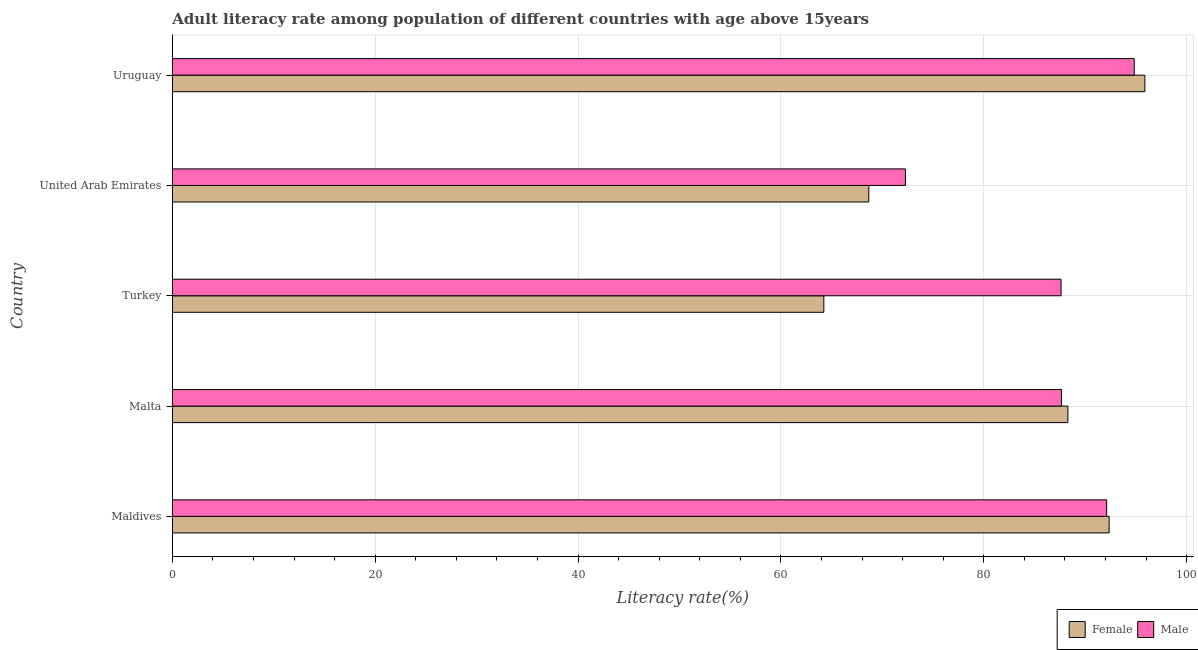How many groups of bars are there?
Your response must be concise. 5. Are the number of bars per tick equal to the number of legend labels?
Ensure brevity in your answer.  Yes. How many bars are there on the 2nd tick from the top?
Provide a succinct answer. 2. What is the label of the 2nd group of bars from the top?
Offer a terse response. United Arab Emirates. What is the male adult literacy rate in Maldives?
Ensure brevity in your answer.  92.11. Across all countries, what is the maximum male adult literacy rate?
Provide a succinct answer. 94.83. Across all countries, what is the minimum male adult literacy rate?
Your response must be concise. 72.27. In which country was the male adult literacy rate maximum?
Keep it short and to the point. Uruguay. In which country was the male adult literacy rate minimum?
Provide a succinct answer. United Arab Emirates. What is the total male adult literacy rate in the graph?
Your response must be concise. 434.5. What is the difference between the male adult literacy rate in Turkey and that in United Arab Emirates?
Give a very brief answer. 15.35. What is the difference between the male adult literacy rate in Malta and the female adult literacy rate in Maldives?
Make the answer very short. -4.7. What is the average male adult literacy rate per country?
Provide a short and direct response. 86.9. What is the difference between the male adult literacy rate and female adult literacy rate in United Arab Emirates?
Provide a short and direct response. 3.61. In how many countries, is the female adult literacy rate greater than 88 %?
Your response must be concise. 3. What is the ratio of the female adult literacy rate in Maldives to that in Turkey?
Your answer should be compact. 1.44. Is the difference between the male adult literacy rate in United Arab Emirates and Uruguay greater than the difference between the female adult literacy rate in United Arab Emirates and Uruguay?
Give a very brief answer. Yes. What is the difference between the highest and the second highest female adult literacy rate?
Give a very brief answer. 3.52. What is the difference between the highest and the lowest male adult literacy rate?
Your answer should be compact. 22.56. What does the 2nd bar from the top in Maldives represents?
Your answer should be compact. Female. What does the 1st bar from the bottom in Turkey represents?
Your answer should be compact. Female. Are all the bars in the graph horizontal?
Your answer should be very brief. Yes. How many countries are there in the graph?
Provide a short and direct response. 5. Are the values on the major ticks of X-axis written in scientific E-notation?
Keep it short and to the point. No. Does the graph contain any zero values?
Offer a terse response. No. Does the graph contain grids?
Keep it short and to the point. Yes. How many legend labels are there?
Offer a terse response. 2. How are the legend labels stacked?
Make the answer very short. Horizontal. What is the title of the graph?
Give a very brief answer. Adult literacy rate among population of different countries with age above 15years. Does "National Visitors" appear as one of the legend labels in the graph?
Offer a very short reply. No. What is the label or title of the X-axis?
Make the answer very short. Literacy rate(%). What is the label or title of the Y-axis?
Your response must be concise. Country. What is the Literacy rate(%) in Female in Maldives?
Your answer should be very brief. 92.36. What is the Literacy rate(%) of Male in Maldives?
Your response must be concise. 92.11. What is the Literacy rate(%) of Female in Malta?
Your answer should be very brief. 88.29. What is the Literacy rate(%) in Male in Malta?
Ensure brevity in your answer.  87.66. What is the Literacy rate(%) of Female in Turkey?
Your answer should be very brief. 64.23. What is the Literacy rate(%) of Male in Turkey?
Your answer should be very brief. 87.62. What is the Literacy rate(%) in Female in United Arab Emirates?
Keep it short and to the point. 68.66. What is the Literacy rate(%) of Male in United Arab Emirates?
Your response must be concise. 72.27. What is the Literacy rate(%) of Female in Uruguay?
Offer a terse response. 95.88. What is the Literacy rate(%) in Male in Uruguay?
Ensure brevity in your answer.  94.83. Across all countries, what is the maximum Literacy rate(%) of Female?
Keep it short and to the point. 95.88. Across all countries, what is the maximum Literacy rate(%) in Male?
Provide a succinct answer. 94.83. Across all countries, what is the minimum Literacy rate(%) in Female?
Provide a short and direct response. 64.23. Across all countries, what is the minimum Literacy rate(%) in Male?
Your response must be concise. 72.27. What is the total Literacy rate(%) in Female in the graph?
Provide a succinct answer. 409.43. What is the total Literacy rate(%) in Male in the graph?
Provide a short and direct response. 434.5. What is the difference between the Literacy rate(%) in Female in Maldives and that in Malta?
Give a very brief answer. 4.07. What is the difference between the Literacy rate(%) of Male in Maldives and that in Malta?
Offer a terse response. 4.46. What is the difference between the Literacy rate(%) in Female in Maldives and that in Turkey?
Provide a succinct answer. 28.13. What is the difference between the Literacy rate(%) of Male in Maldives and that in Turkey?
Your answer should be compact. 4.49. What is the difference between the Literacy rate(%) in Female in Maldives and that in United Arab Emirates?
Ensure brevity in your answer.  23.7. What is the difference between the Literacy rate(%) in Male in Maldives and that in United Arab Emirates?
Make the answer very short. 19.84. What is the difference between the Literacy rate(%) of Female in Maldives and that in Uruguay?
Your response must be concise. -3.52. What is the difference between the Literacy rate(%) of Male in Maldives and that in Uruguay?
Give a very brief answer. -2.72. What is the difference between the Literacy rate(%) of Female in Malta and that in Turkey?
Provide a short and direct response. 24.06. What is the difference between the Literacy rate(%) in Male in Malta and that in Turkey?
Offer a very short reply. 0.04. What is the difference between the Literacy rate(%) of Female in Malta and that in United Arab Emirates?
Make the answer very short. 19.63. What is the difference between the Literacy rate(%) of Male in Malta and that in United Arab Emirates?
Ensure brevity in your answer.  15.38. What is the difference between the Literacy rate(%) of Female in Malta and that in Uruguay?
Provide a succinct answer. -7.59. What is the difference between the Literacy rate(%) of Male in Malta and that in Uruguay?
Provide a succinct answer. -7.18. What is the difference between the Literacy rate(%) in Female in Turkey and that in United Arab Emirates?
Ensure brevity in your answer.  -4.43. What is the difference between the Literacy rate(%) of Male in Turkey and that in United Arab Emirates?
Your answer should be very brief. 15.35. What is the difference between the Literacy rate(%) of Female in Turkey and that in Uruguay?
Keep it short and to the point. -31.65. What is the difference between the Literacy rate(%) of Male in Turkey and that in Uruguay?
Ensure brevity in your answer.  -7.21. What is the difference between the Literacy rate(%) in Female in United Arab Emirates and that in Uruguay?
Offer a terse response. -27.22. What is the difference between the Literacy rate(%) of Male in United Arab Emirates and that in Uruguay?
Keep it short and to the point. -22.56. What is the difference between the Literacy rate(%) of Female in Maldives and the Literacy rate(%) of Male in Malta?
Provide a succinct answer. 4.7. What is the difference between the Literacy rate(%) of Female in Maldives and the Literacy rate(%) of Male in Turkey?
Your answer should be very brief. 4.74. What is the difference between the Literacy rate(%) of Female in Maldives and the Literacy rate(%) of Male in United Arab Emirates?
Your answer should be compact. 20.08. What is the difference between the Literacy rate(%) of Female in Maldives and the Literacy rate(%) of Male in Uruguay?
Your response must be concise. -2.47. What is the difference between the Literacy rate(%) in Female in Malta and the Literacy rate(%) in Male in Turkey?
Make the answer very short. 0.67. What is the difference between the Literacy rate(%) of Female in Malta and the Literacy rate(%) of Male in United Arab Emirates?
Offer a very short reply. 16.02. What is the difference between the Literacy rate(%) of Female in Malta and the Literacy rate(%) of Male in Uruguay?
Offer a terse response. -6.54. What is the difference between the Literacy rate(%) in Female in Turkey and the Literacy rate(%) in Male in United Arab Emirates?
Make the answer very short. -8.04. What is the difference between the Literacy rate(%) of Female in Turkey and the Literacy rate(%) of Male in Uruguay?
Your response must be concise. -30.6. What is the difference between the Literacy rate(%) in Female in United Arab Emirates and the Literacy rate(%) in Male in Uruguay?
Provide a succinct answer. -26.17. What is the average Literacy rate(%) of Female per country?
Keep it short and to the point. 81.89. What is the average Literacy rate(%) of Male per country?
Offer a very short reply. 86.9. What is the difference between the Literacy rate(%) in Female and Literacy rate(%) in Male in Maldives?
Your answer should be compact. 0.24. What is the difference between the Literacy rate(%) in Female and Literacy rate(%) in Male in Malta?
Your answer should be very brief. 0.64. What is the difference between the Literacy rate(%) in Female and Literacy rate(%) in Male in Turkey?
Give a very brief answer. -23.39. What is the difference between the Literacy rate(%) in Female and Literacy rate(%) in Male in United Arab Emirates?
Provide a succinct answer. -3.61. What is the difference between the Literacy rate(%) in Female and Literacy rate(%) in Male in Uruguay?
Provide a succinct answer. 1.05. What is the ratio of the Literacy rate(%) in Female in Maldives to that in Malta?
Your response must be concise. 1.05. What is the ratio of the Literacy rate(%) of Male in Maldives to that in Malta?
Keep it short and to the point. 1.05. What is the ratio of the Literacy rate(%) in Female in Maldives to that in Turkey?
Provide a succinct answer. 1.44. What is the ratio of the Literacy rate(%) in Male in Maldives to that in Turkey?
Offer a terse response. 1.05. What is the ratio of the Literacy rate(%) in Female in Maldives to that in United Arab Emirates?
Your response must be concise. 1.35. What is the ratio of the Literacy rate(%) in Male in Maldives to that in United Arab Emirates?
Provide a succinct answer. 1.27. What is the ratio of the Literacy rate(%) in Female in Maldives to that in Uruguay?
Offer a terse response. 0.96. What is the ratio of the Literacy rate(%) in Male in Maldives to that in Uruguay?
Your response must be concise. 0.97. What is the ratio of the Literacy rate(%) in Female in Malta to that in Turkey?
Your answer should be compact. 1.37. What is the ratio of the Literacy rate(%) in Female in Malta to that in United Arab Emirates?
Provide a succinct answer. 1.29. What is the ratio of the Literacy rate(%) of Male in Malta to that in United Arab Emirates?
Give a very brief answer. 1.21. What is the ratio of the Literacy rate(%) in Female in Malta to that in Uruguay?
Provide a succinct answer. 0.92. What is the ratio of the Literacy rate(%) in Male in Malta to that in Uruguay?
Give a very brief answer. 0.92. What is the ratio of the Literacy rate(%) in Female in Turkey to that in United Arab Emirates?
Your answer should be very brief. 0.94. What is the ratio of the Literacy rate(%) of Male in Turkey to that in United Arab Emirates?
Offer a very short reply. 1.21. What is the ratio of the Literacy rate(%) in Female in Turkey to that in Uruguay?
Make the answer very short. 0.67. What is the ratio of the Literacy rate(%) in Male in Turkey to that in Uruguay?
Provide a short and direct response. 0.92. What is the ratio of the Literacy rate(%) in Female in United Arab Emirates to that in Uruguay?
Your answer should be compact. 0.72. What is the ratio of the Literacy rate(%) in Male in United Arab Emirates to that in Uruguay?
Offer a terse response. 0.76. What is the difference between the highest and the second highest Literacy rate(%) of Female?
Make the answer very short. 3.52. What is the difference between the highest and the second highest Literacy rate(%) of Male?
Provide a short and direct response. 2.72. What is the difference between the highest and the lowest Literacy rate(%) of Female?
Offer a terse response. 31.65. What is the difference between the highest and the lowest Literacy rate(%) in Male?
Your response must be concise. 22.56. 